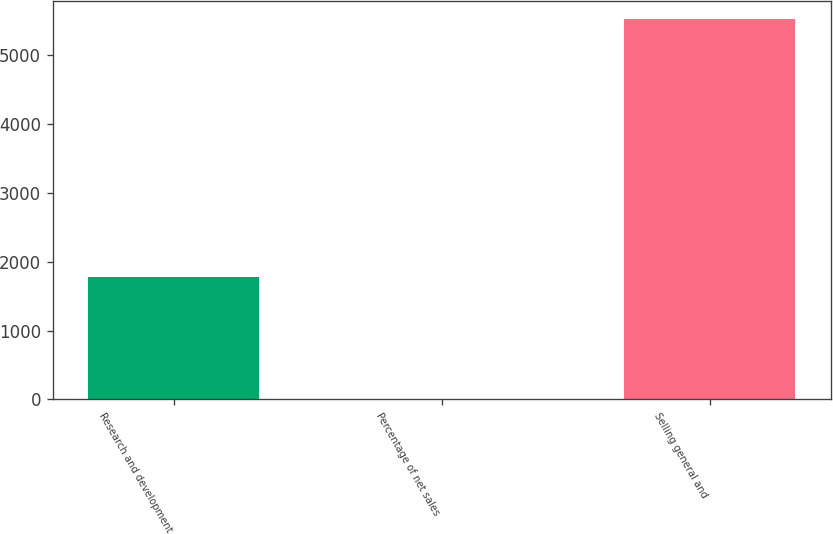<chart> <loc_0><loc_0><loc_500><loc_500><bar_chart><fcel>Research and development<fcel>Percentage of net sales<fcel>Selling general and<nl><fcel>1782<fcel>2.7<fcel>5517<nl></chart> 